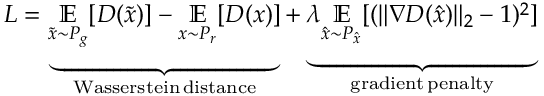<formula> <loc_0><loc_0><loc_500><loc_500>L = \underbrace { \underset { \tilde { x } \sim P _ { g } } { \mathbb { E } } [ D ( \tilde { x } ) ] - \underset { x \sim P _ { r } } { \mathbb { E } } [ D ( x ) ] } _ { W a s s e r s t e i n \, d i s t a n c e } + \underbrace { \lambda \underset { \hat { x } \sim P _ { \hat { x } } } { \mathbb { E } } [ ( \| \nabla D ( \hat { x } ) \| _ { 2 } - 1 ) ^ { 2 } ] } _ { g r a d i e n t \, p e n a l t y }</formula> 